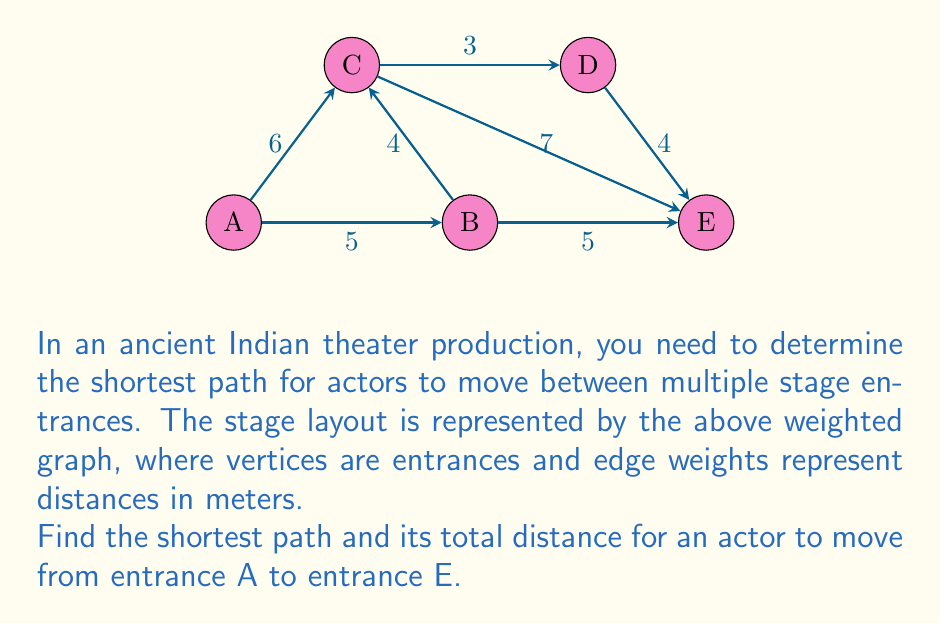Can you solve this math problem? To solve this problem, we'll use Dijkstra's algorithm to find the shortest path from A to E. Here's the step-by-step process:

1) Initialize:
   - Distance to A: 0
   - Distance to all other vertices: $\infty$
   - Set of unvisited nodes: {A, B, C, D, E}

2) From A:
   - Update distances: A->B (5), A->C (6)
   - Mark A as visited
   - Unvisited set: {B, C, D, E}

3) Select B (shortest distance from A):
   - Update distances: B->C (min(6, 5+4) = 6), B->E (5+5 = 10)
   - Mark B as visited
   - Unvisited set: {C, D, E}

4) Select C (shortest distance from A):
   - Update distances: C->D (6+3 = 9), C->E (min(10, 6+7) = 10)
   - Mark C as visited
   - Unvisited set: {D, E}

5) Select D (shortest distance from A):
   - Update distances: D->E (min(10, 9+4) = 9)
   - Mark D as visited
   - Unvisited set: {E}

6) Select E (last unvisited node):
   - Mark E as visited
   - Algorithm complete

The shortest path from A to E is A -> C -> D -> E with a total distance of 9 meters.
Answer: A -> C -> D -> E, 9 meters 